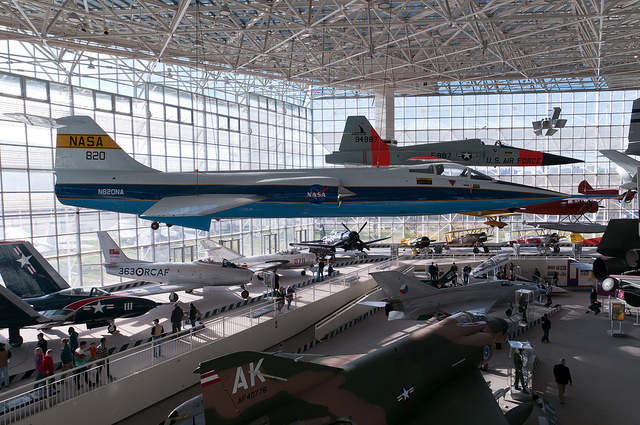Please transcribe the text in this image. NASA NASA 820 NBZONA 94967 AK AF40776 RCAF 363 FORCE U.S. AIR 87 879 